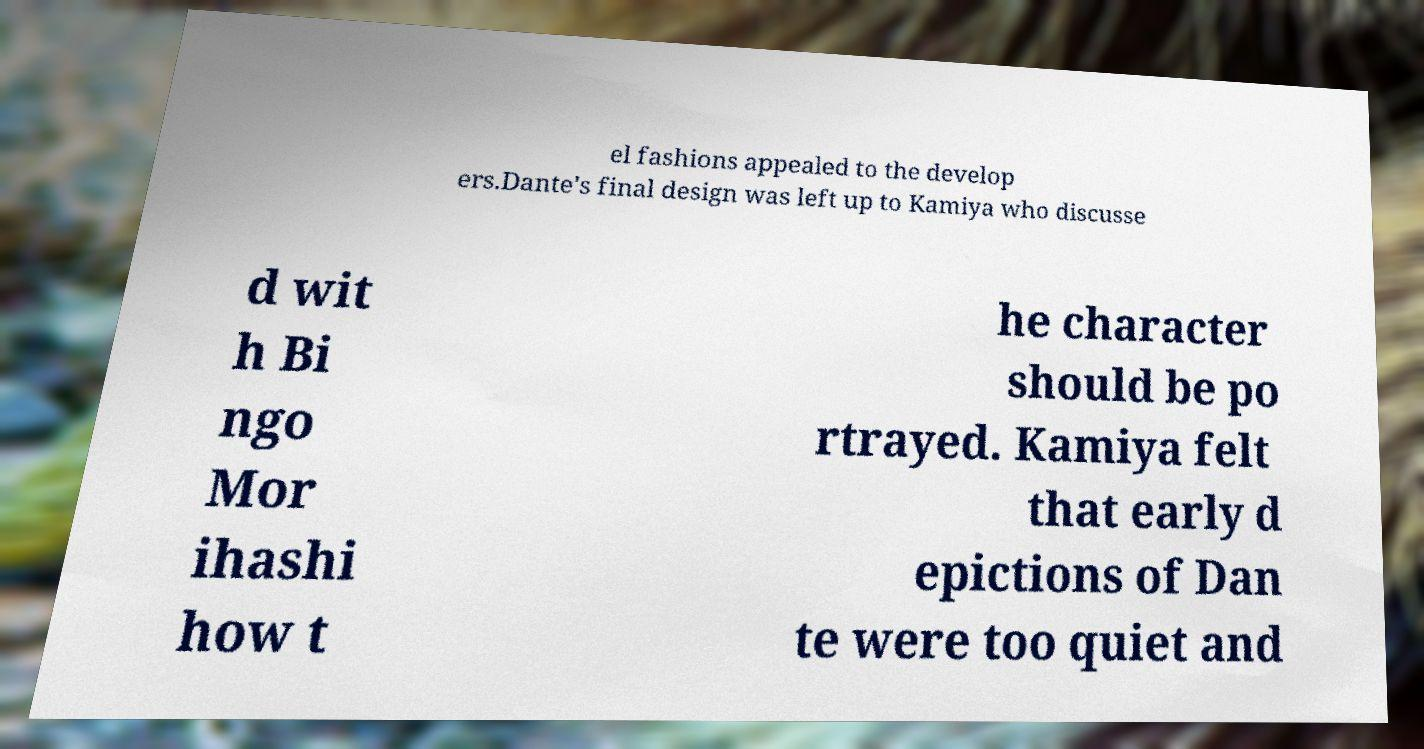There's text embedded in this image that I need extracted. Can you transcribe it verbatim? el fashions appealed to the develop ers.Dante's final design was left up to Kamiya who discusse d wit h Bi ngo Mor ihashi how t he character should be po rtrayed. Kamiya felt that early d epictions of Dan te were too quiet and 